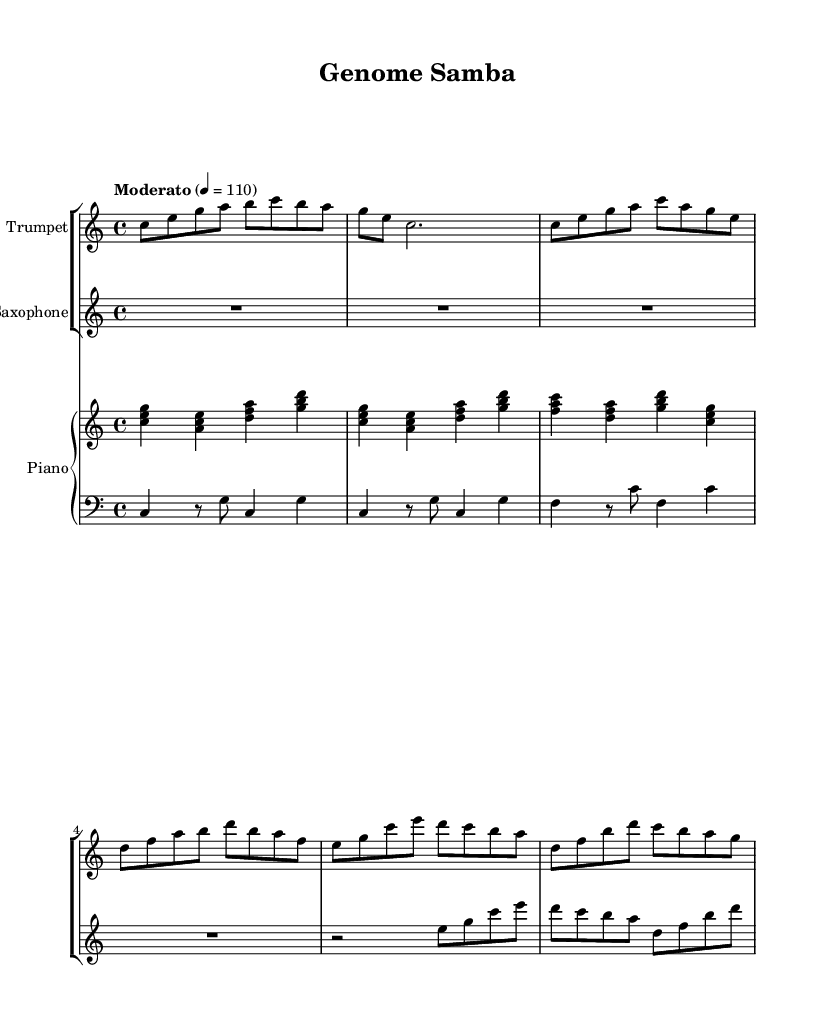What is the key signature of this music? The key signature is indicated by the notes used in the piece. In this case, the music is written in C major, which has no sharps or flats.
Answer: C major What is the time signature of this piece? The time signature is shown at the beginning of the score, which is 4/4. This indicates that there are four beats in each measure.
Answer: 4/4 What is the tempo marking for this composition? The tempo is provided in the score as "Moderato," with a metronome marking of 110 beats per minute, indicating a moderate speed.
Answer: Moderato How many measures are there in the trumpet part? Counting the measures in the trumpet music section, there are a total of five measures present in this part.
Answer: 5 What is the rhythmic pattern used in the piano left hand? By analyzing the left hand piano music notation, it shows a rhythmic pattern that alternates between four quarter notes and rests. Specifically, it occurs in a syncopated fashion, typical in jazz settings.
Answer: Alternating quarter notes What unique characteristics define the genre of Latin jazz in this piece? Latin jazz often incorporates syncopation, rhythmic complexity, and a fusion of jazz with Latin music elements. The use of instruments like trumpet and saxophone alongside rhythmic patterns in the piano exemplifies this genre.
Answer: Syncopation, rhythmic complexity What type of chords are used in the piano right hand? The chords in the piano right hand are broken chords played as triads, which are typical in jazz genres. The use of major and minor chords creates a rich harmonic texture.
Answer: Triads 